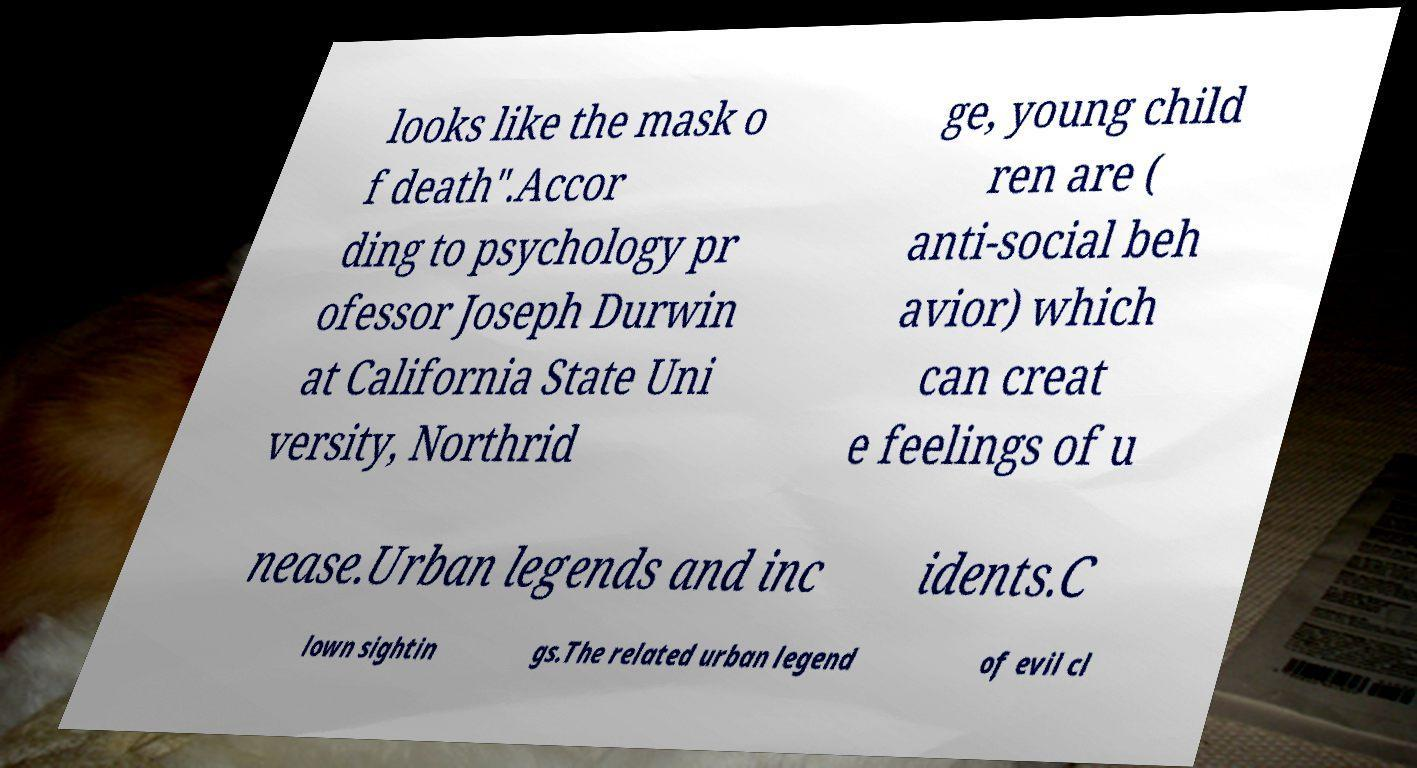For documentation purposes, I need the text within this image transcribed. Could you provide that? looks like the mask o f death".Accor ding to psychology pr ofessor Joseph Durwin at California State Uni versity, Northrid ge, young child ren are ( anti-social beh avior) which can creat e feelings of u nease.Urban legends and inc idents.C lown sightin gs.The related urban legend of evil cl 